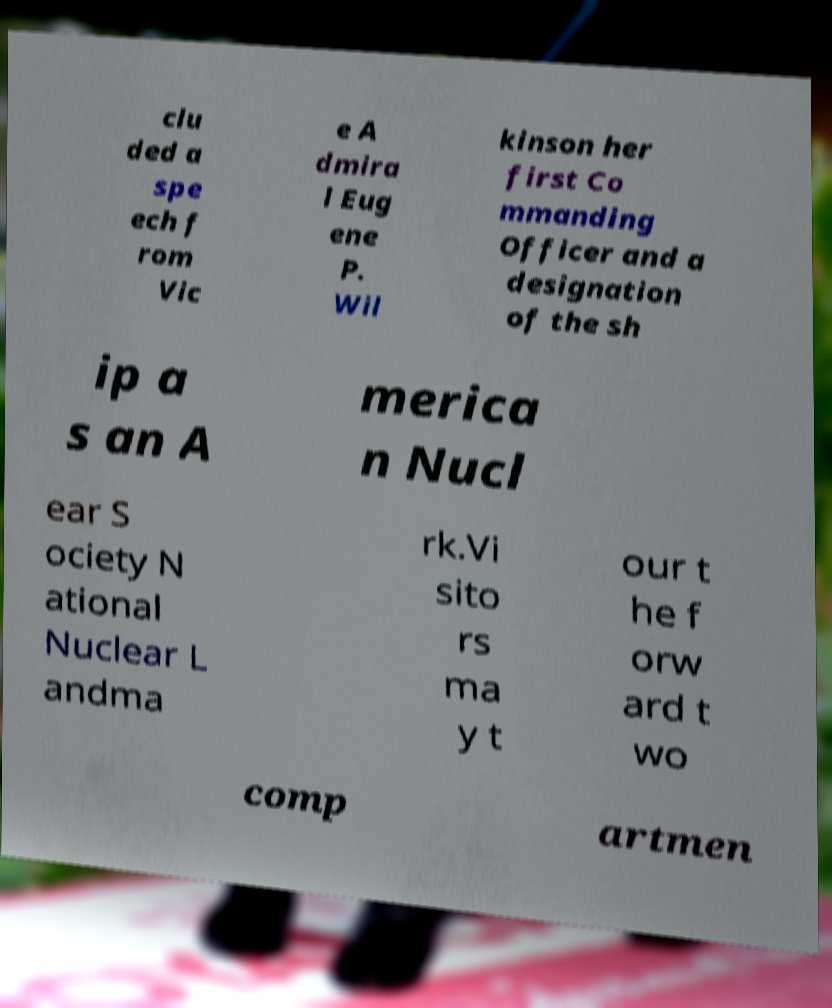For documentation purposes, I need the text within this image transcribed. Could you provide that? clu ded a spe ech f rom Vic e A dmira l Eug ene P. Wil kinson her first Co mmanding Officer and a designation of the sh ip a s an A merica n Nucl ear S ociety N ational Nuclear L andma rk.Vi sito rs ma y t our t he f orw ard t wo comp artmen 